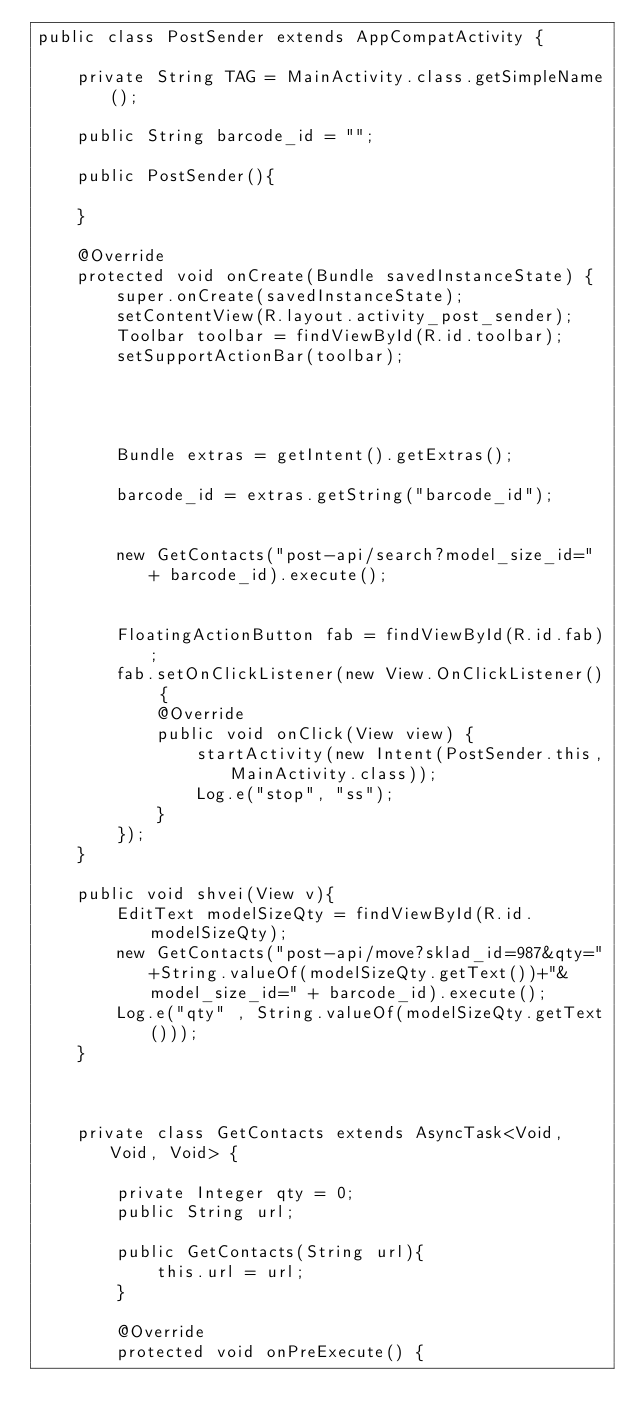Convert code to text. <code><loc_0><loc_0><loc_500><loc_500><_Java_>public class PostSender extends AppCompatActivity {

    private String TAG = MainActivity.class.getSimpleName();

    public String barcode_id = "";

    public PostSender(){

    }

    @Override
    protected void onCreate(Bundle savedInstanceState) {
        super.onCreate(savedInstanceState);
        setContentView(R.layout.activity_post_sender);
        Toolbar toolbar = findViewById(R.id.toolbar);
        setSupportActionBar(toolbar);




        Bundle extras = getIntent().getExtras();

        barcode_id = extras.getString("barcode_id");


        new GetContacts("post-api/search?model_size_id=" + barcode_id).execute();


        FloatingActionButton fab = findViewById(R.id.fab);
        fab.setOnClickListener(new View.OnClickListener() {
            @Override
            public void onClick(View view) {
                startActivity(new Intent(PostSender.this,MainActivity.class));
                Log.e("stop", "ss");
            }
        });
    }

    public void shvei(View v){
        EditText modelSizeQty = findViewById(R.id.modelSizeQty);
        new GetContacts("post-api/move?sklad_id=987&qty="+String.valueOf(modelSizeQty.getText())+"&model_size_id=" + barcode_id).execute();
        Log.e("qty" , String.valueOf(modelSizeQty.getText()));
    }



    private class GetContacts extends AsyncTask<Void, Void, Void> {

        private Integer qty = 0;
        public String url;

        public GetContacts(String url){
            this.url = url;
        }

        @Override
        protected void onPreExecute() {</code> 